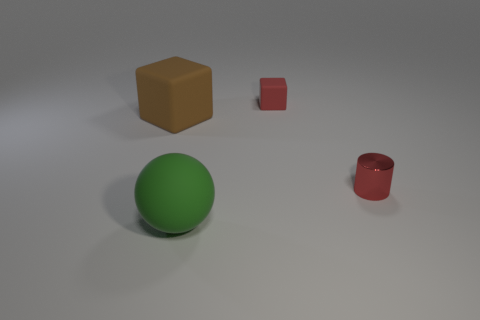Add 1 matte spheres. How many objects exist? 5 Subtract all red blocks. How many blocks are left? 1 Subtract 0 purple cylinders. How many objects are left? 4 Subtract all cylinders. How many objects are left? 3 Subtract all gray blocks. Subtract all gray cylinders. How many blocks are left? 2 Subtract all gray balls. How many red cubes are left? 1 Subtract all tiny brown blocks. Subtract all big balls. How many objects are left? 3 Add 3 red cylinders. How many red cylinders are left? 4 Add 4 shiny balls. How many shiny balls exist? 4 